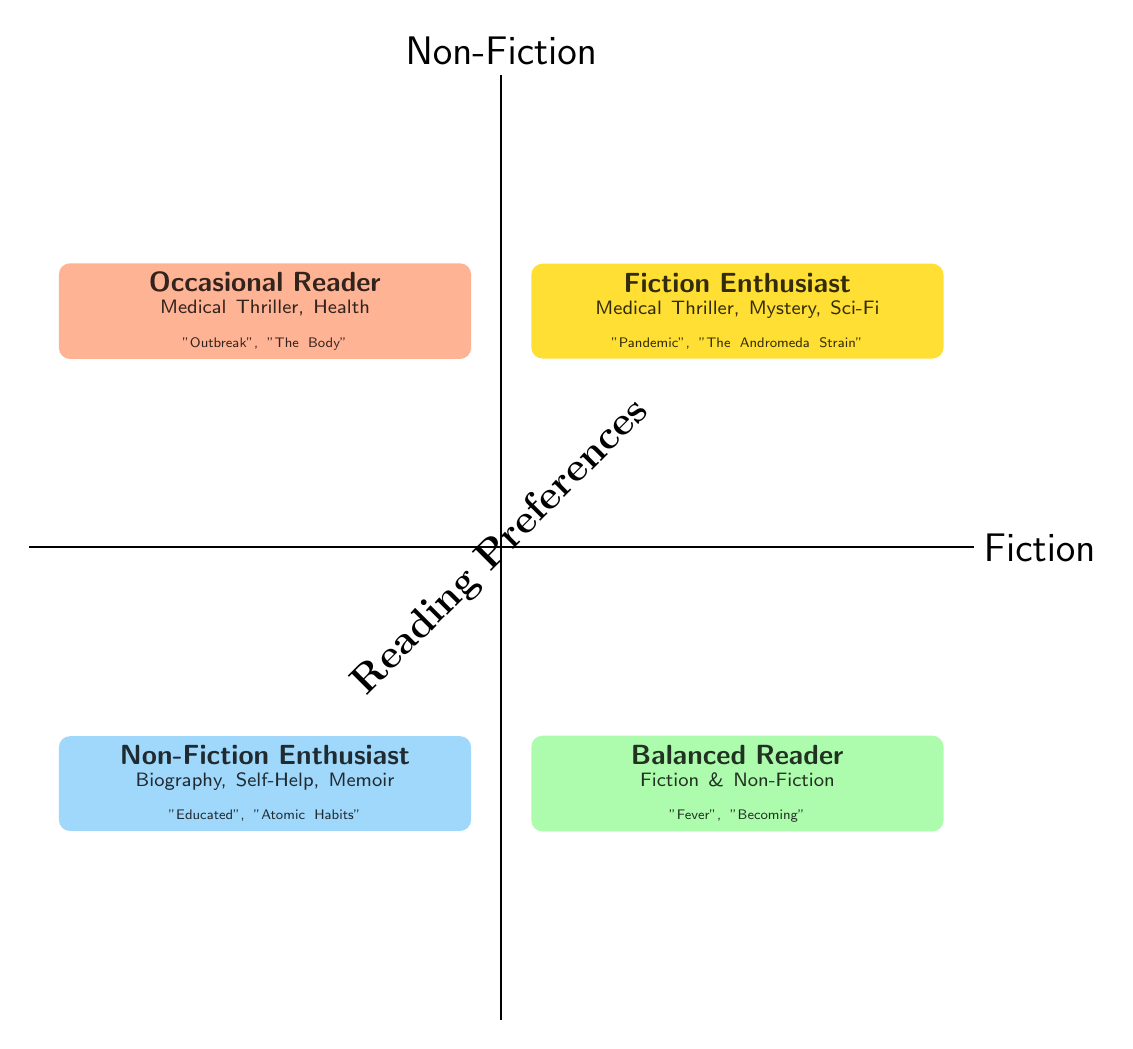What quadrant represents readers who primarily enjoy fiction? The "Fiction Enthusiast" quadrant is located in the top right of the diagram, indicating it includes those who primarily enjoy fiction.
Answer: Fiction Enthusiast How many popular titles are listed for the Non-Fiction Enthusiast quadrant? The "Non-Fiction Enthusiast" quadrant lists three popular titles, which are "Educated," "The Immortal Life of Henrietta Lacks," and "Atomic Habits."
Answer: 3 Which quadrant contains "Fever" as a popular fiction title? The "Balanced Reader" quadrant includes the popular fiction title "Fever," indicating they enjoy both fiction and non-fiction.
Answer: Balanced Reader What genre examples are provided for the Occasional Reader? The Occasional Reader quadrant provides examples for "Medical Thriller" and "Health," indicating the types of literature this group engages with.
Answer: Medical Thriller, Health Which two quadrants contain popular titles related to Medical Thrillers? The "Fiction Enthusiast" quadrant features titles like "Pandemic" and "The Occasional Reader" has "Outbreak," showing both preferences for Medical Thrillers.
Answer: Fiction Enthusiast, Occasional Reader What type of reader is found in the bottom right quadrant? The bottom right quadrant is designated for the "Balanced Reader," which represents those who enjoy both fiction and non-fiction equally.
Answer: Balanced Reader How do the genres of the Non-Fiction Enthusiast differ from those of the Fiction Enthusiast? The Non-Fiction Enthusiast primarily enjoys "Biography," "Self-Help," and "Memoir," while the Fiction Enthusiast enjoys "Medical Thriller," "Mystery," and "Sci-Fi," indicating a clear difference in genre preferences.
Answer: They differ significantly What activities are associated with the Fiction Enthusiast? The activities associated with the "Fiction Enthusiast" include "Book club discussions" and "Online forums," which highlight how they engage with literature.
Answer: Book club discussions, Online forums 